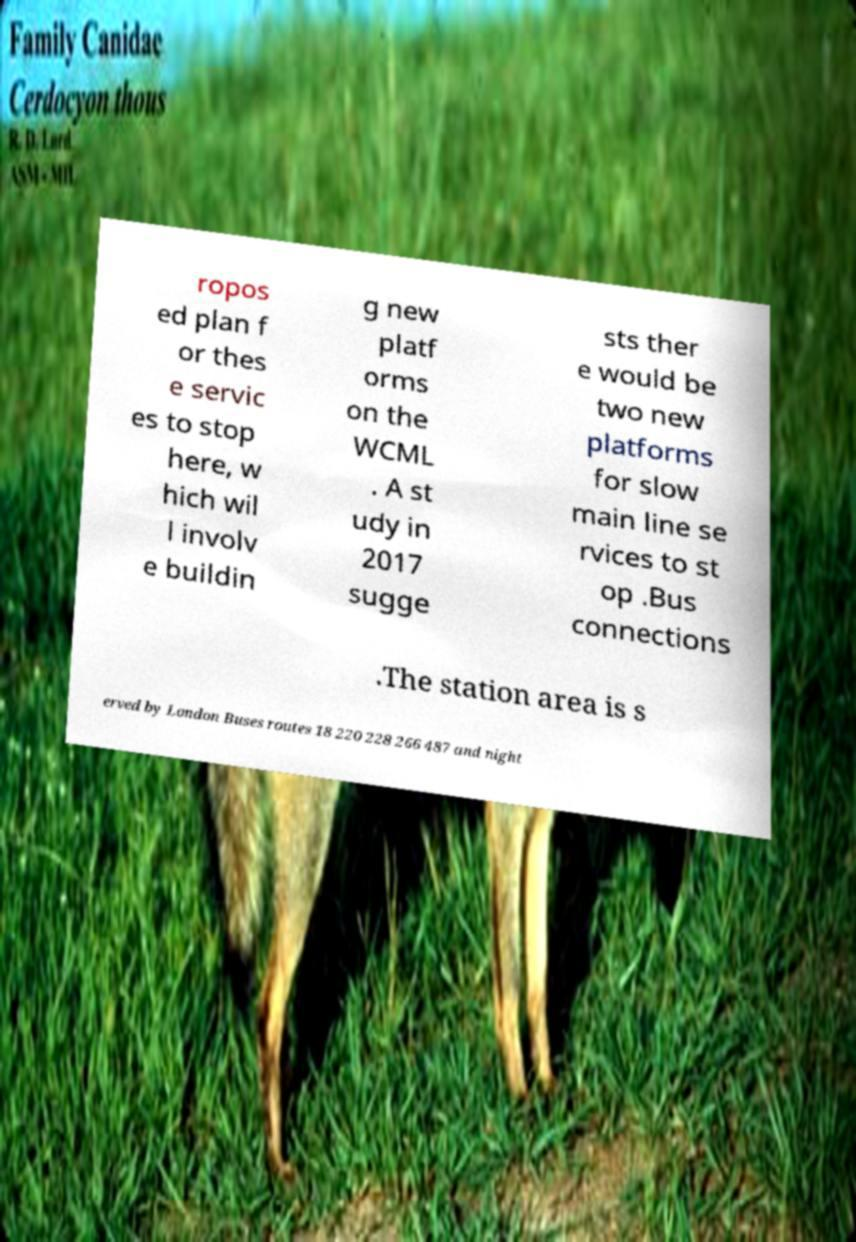What messages or text are displayed in this image? I need them in a readable, typed format. ropos ed plan f or thes e servic es to stop here, w hich wil l involv e buildin g new platf orms on the WCML . A st udy in 2017 sugge sts ther e would be two new platforms for slow main line se rvices to st op .Bus connections .The station area is s erved by London Buses routes 18 220 228 266 487 and night 